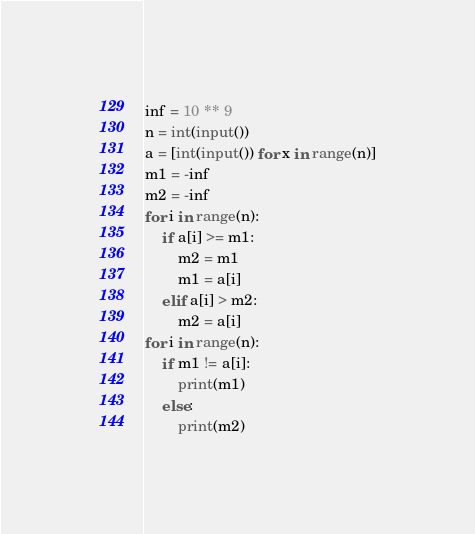<code> <loc_0><loc_0><loc_500><loc_500><_Python_>inf = 10 ** 9
n = int(input())
a = [int(input()) for x in range(n)]
m1 = -inf
m2 = -inf
for i in range(n):
    if a[i] >= m1:
        m2 = m1
        m1 = a[i]
    elif a[i] > m2:
        m2 = a[i]
for i in range(n):
    if m1 != a[i]:
        print(m1)
    else:
        print(m2)</code> 